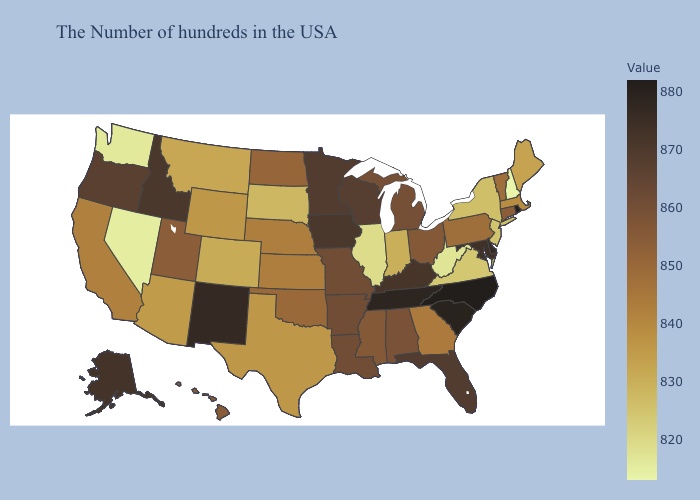Among the states that border Florida , which have the lowest value?
Be succinct. Georgia. Does Colorado have a lower value than Washington?
Write a very short answer. No. Which states hav the highest value in the Northeast?
Write a very short answer. Rhode Island. Does Alabama have a lower value than North Carolina?
Be succinct. Yes. Does California have the highest value in the West?
Be succinct. No. Does North Carolina have a lower value than Wisconsin?
Give a very brief answer. No. Does the map have missing data?
Short answer required. No. 